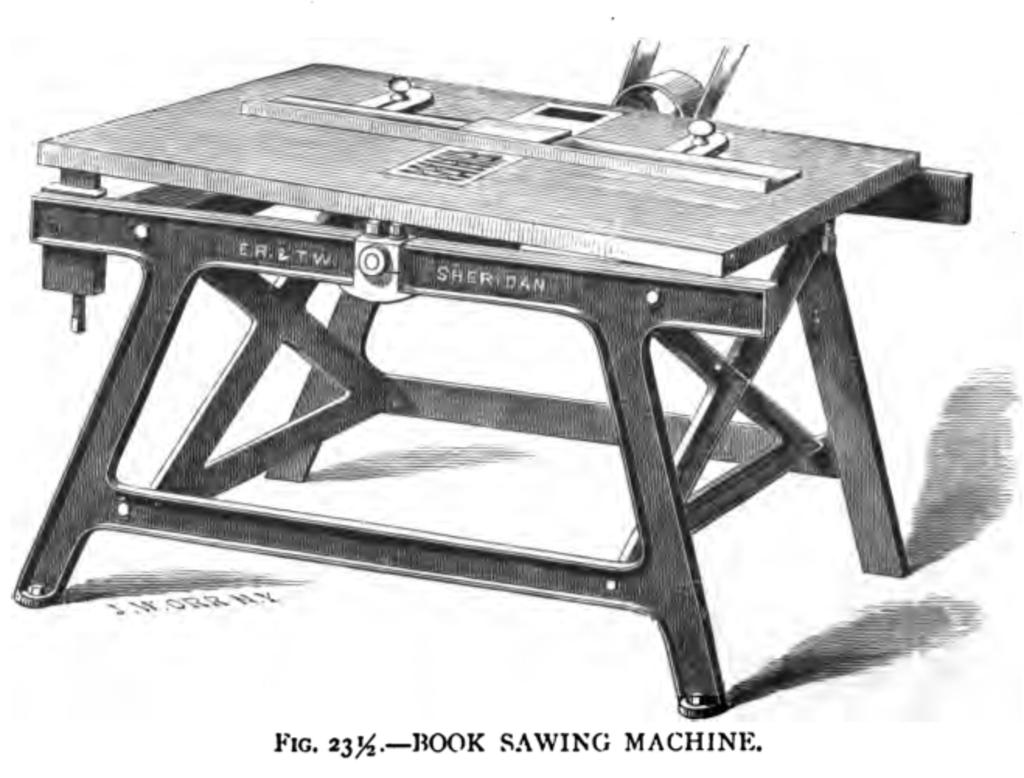What is featured in the image in the form of a printed material? There is a poster in the image. What is depicted on the poster? The poster contains an image of a table. Is there any text present on the poster? Yes, there is text on the poster. What type of yarn is being used to create the table in the image? There is no yarn present in the image; the table is depicted in an image on the poster. Can you see any boats in the image? No, there are no boats present in the image. 